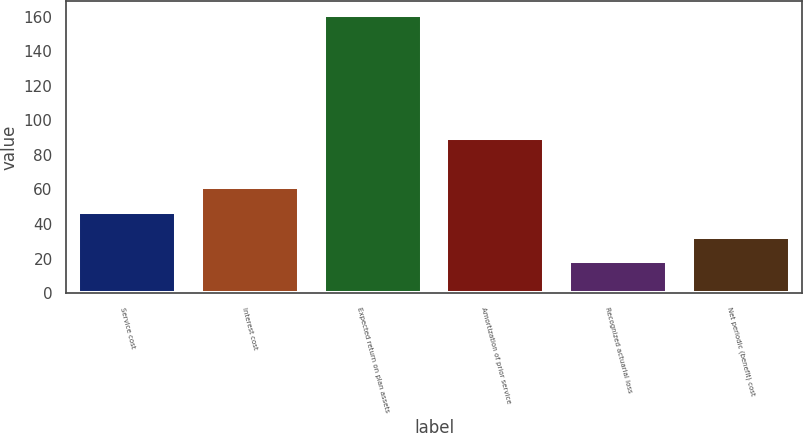Convert chart to OTSL. <chart><loc_0><loc_0><loc_500><loc_500><bar_chart><fcel>Service cost<fcel>Interest cost<fcel>Expected return on plan assets<fcel>Amortization of prior service<fcel>Recognized actuarial loss<fcel>Net periodic (benefit) cost<nl><fcel>46.86<fcel>61.09<fcel>160.7<fcel>90<fcel>18.4<fcel>32.63<nl></chart> 